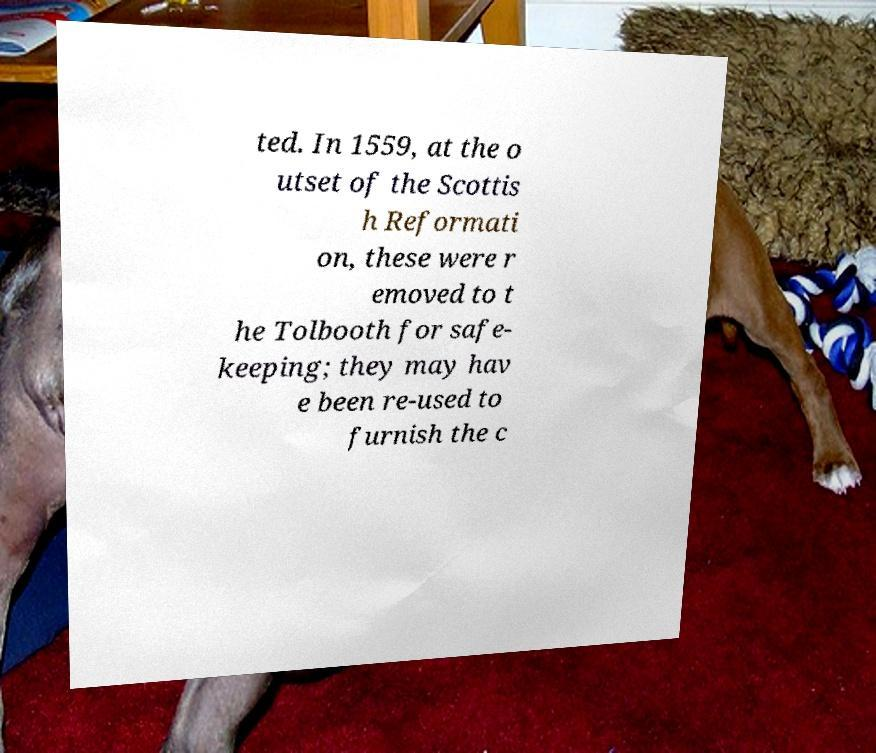Could you extract and type out the text from this image? ted. In 1559, at the o utset of the Scottis h Reformati on, these were r emoved to t he Tolbooth for safe- keeping; they may hav e been re-used to furnish the c 